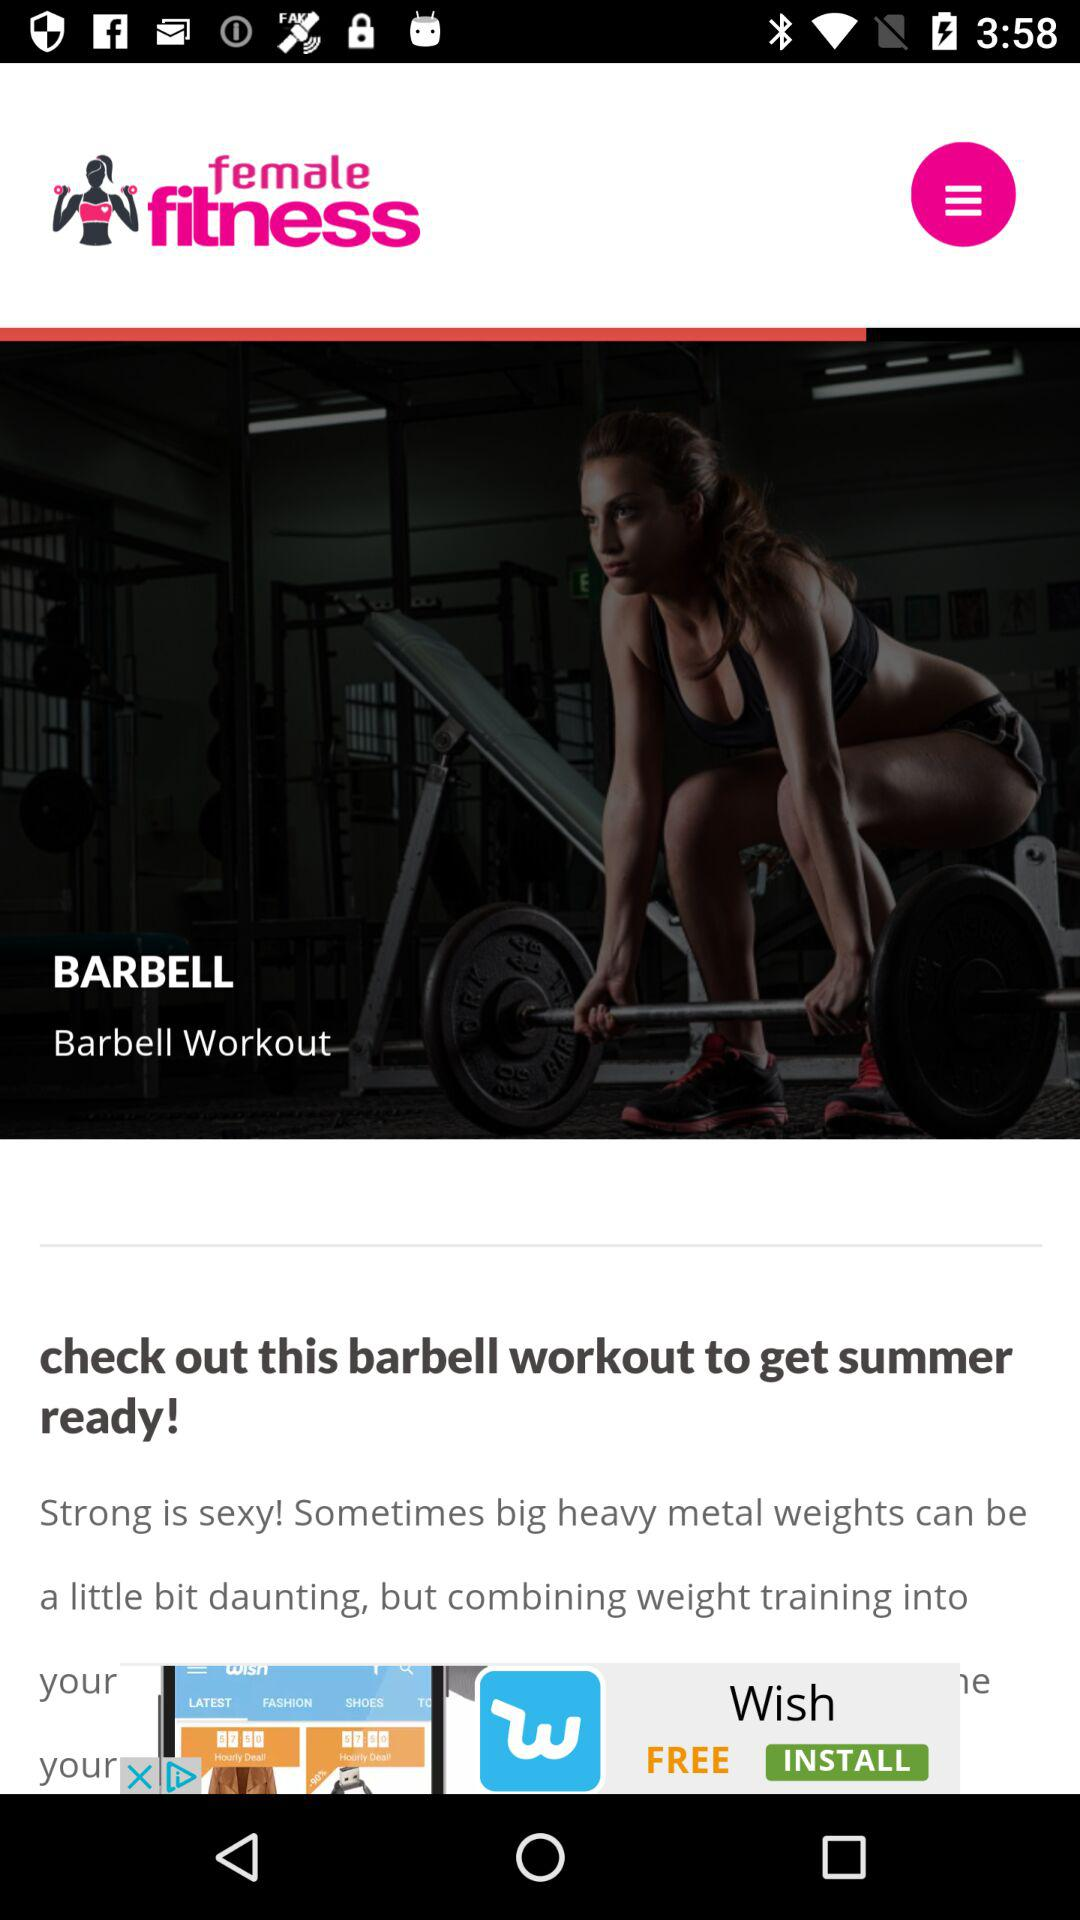What is the name of the workout? The name of the workout is Barbell. 